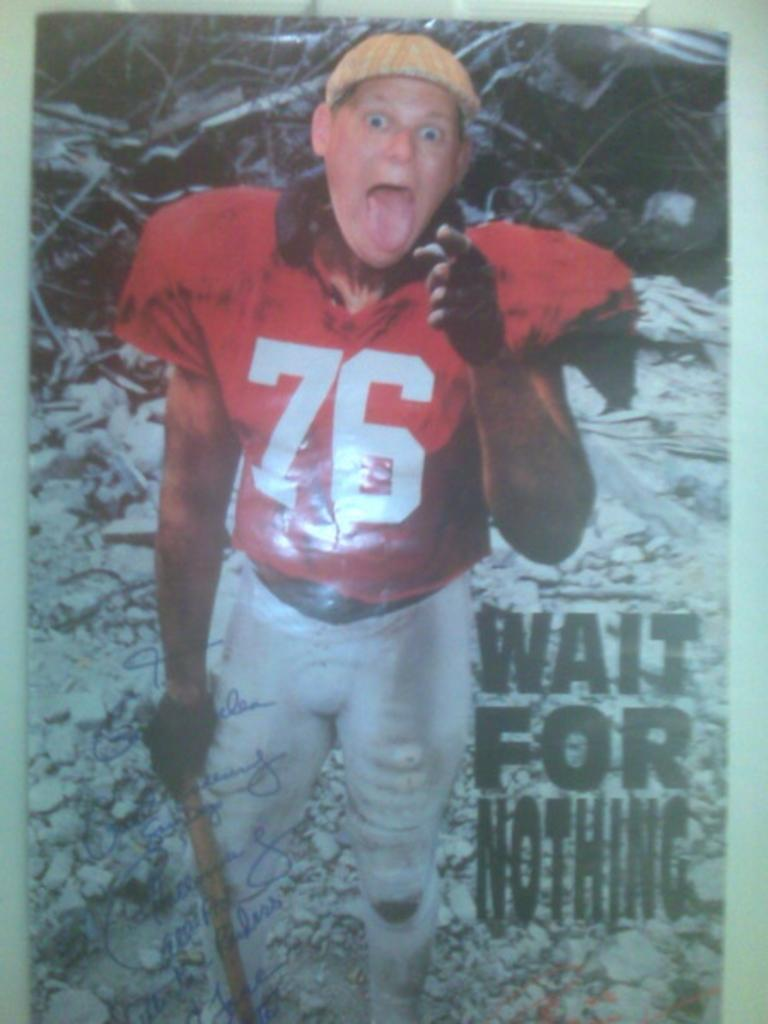<image>
Describe the image concisely. A poster of football player number 76 with the caption, "Wait for Nothing". 